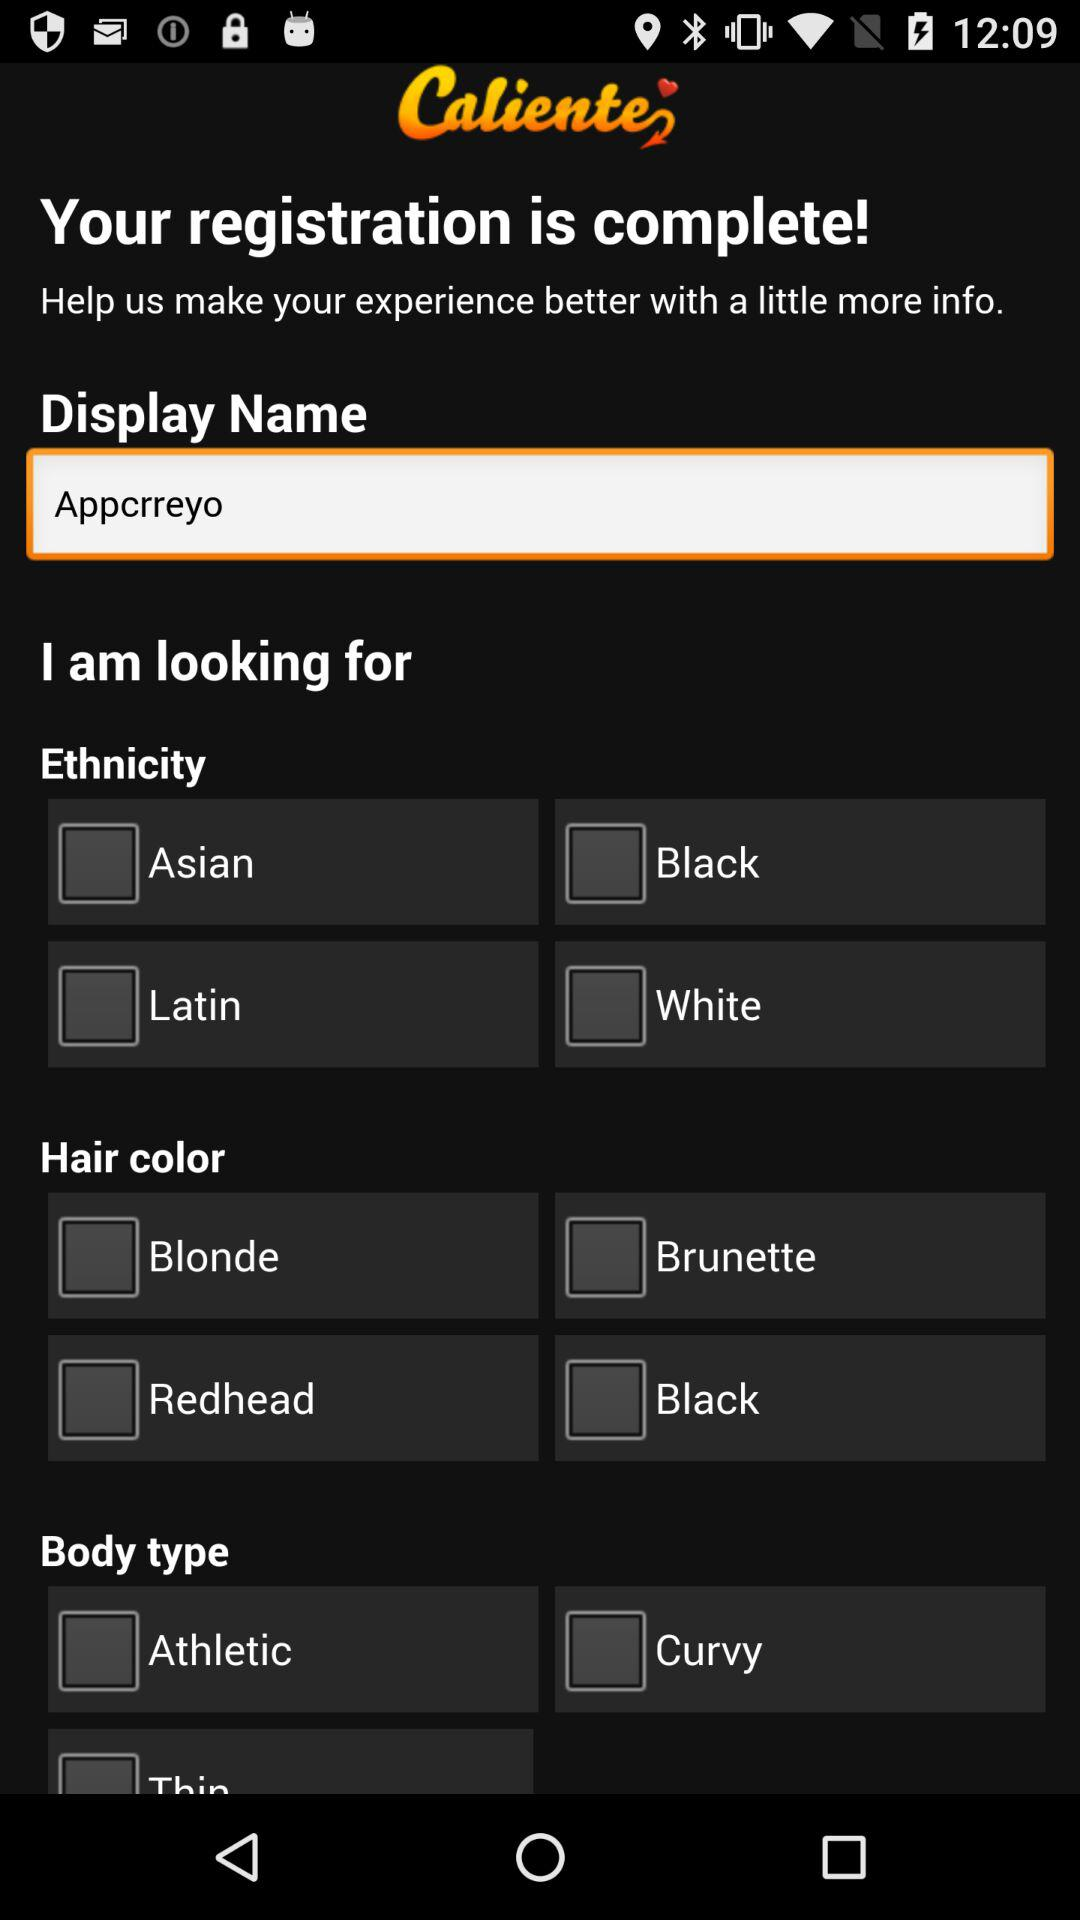How many ethnicity options are there?
Answer the question using a single word or phrase. 4 